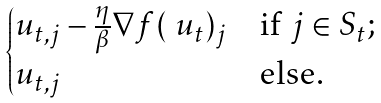<formula> <loc_0><loc_0><loc_500><loc_500>\begin{cases} u _ { t , j } - \frac { \eta } { \beta } \nabla f ( \ u _ { t } ) _ { j } & \text {if $j \in S_{t};$} \\ u _ { t , j } & \text {else.} \end{cases}</formula> 